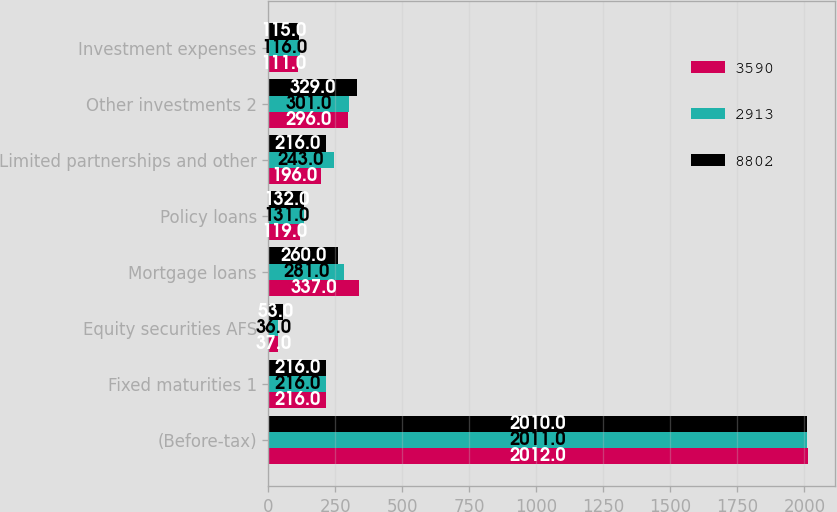Convert chart to OTSL. <chart><loc_0><loc_0><loc_500><loc_500><stacked_bar_chart><ecel><fcel>(Before-tax)<fcel>Fixed maturities 1<fcel>Equity securities AFS<fcel>Mortgage loans<fcel>Policy loans<fcel>Limited partnerships and other<fcel>Other investments 2<fcel>Investment expenses<nl><fcel>3590<fcel>2012<fcel>216<fcel>37<fcel>337<fcel>119<fcel>196<fcel>296<fcel>111<nl><fcel>2913<fcel>2011<fcel>216<fcel>36<fcel>281<fcel>131<fcel>243<fcel>301<fcel>116<nl><fcel>8802<fcel>2010<fcel>216<fcel>53<fcel>260<fcel>132<fcel>216<fcel>329<fcel>115<nl></chart> 